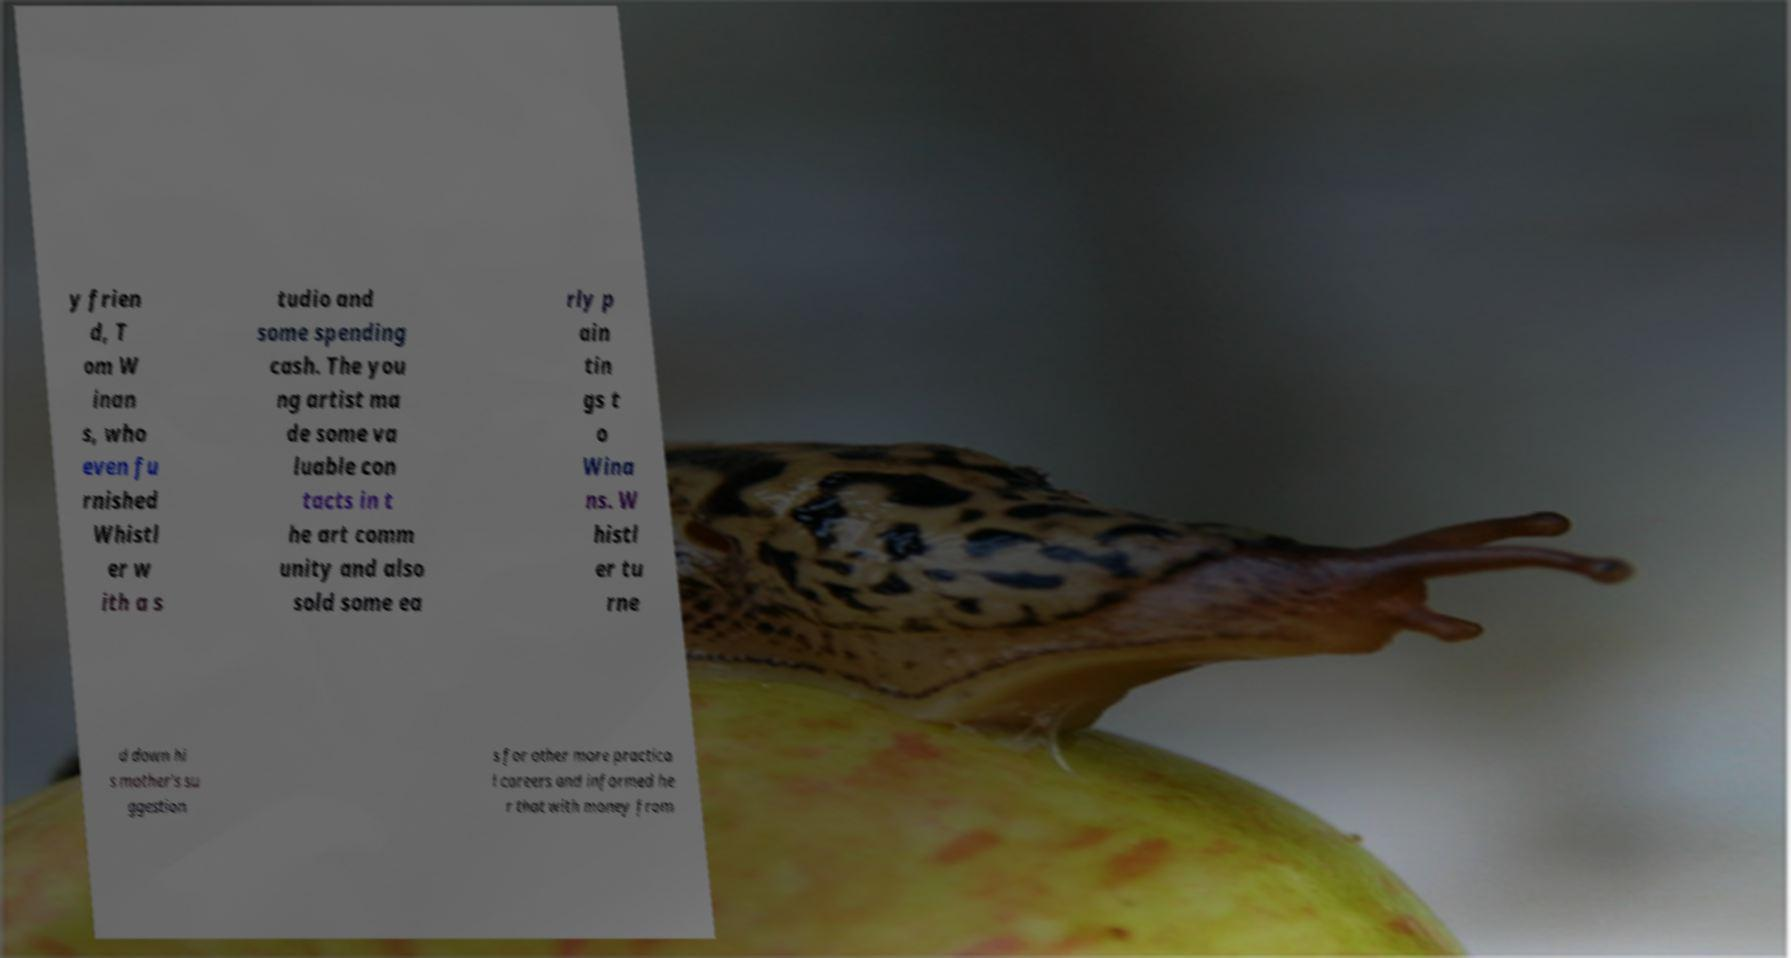Could you assist in decoding the text presented in this image and type it out clearly? y frien d, T om W inan s, who even fu rnished Whistl er w ith a s tudio and some spending cash. The you ng artist ma de some va luable con tacts in t he art comm unity and also sold some ea rly p ain tin gs t o Wina ns. W histl er tu rne d down hi s mother's su ggestion s for other more practica l careers and informed he r that with money from 